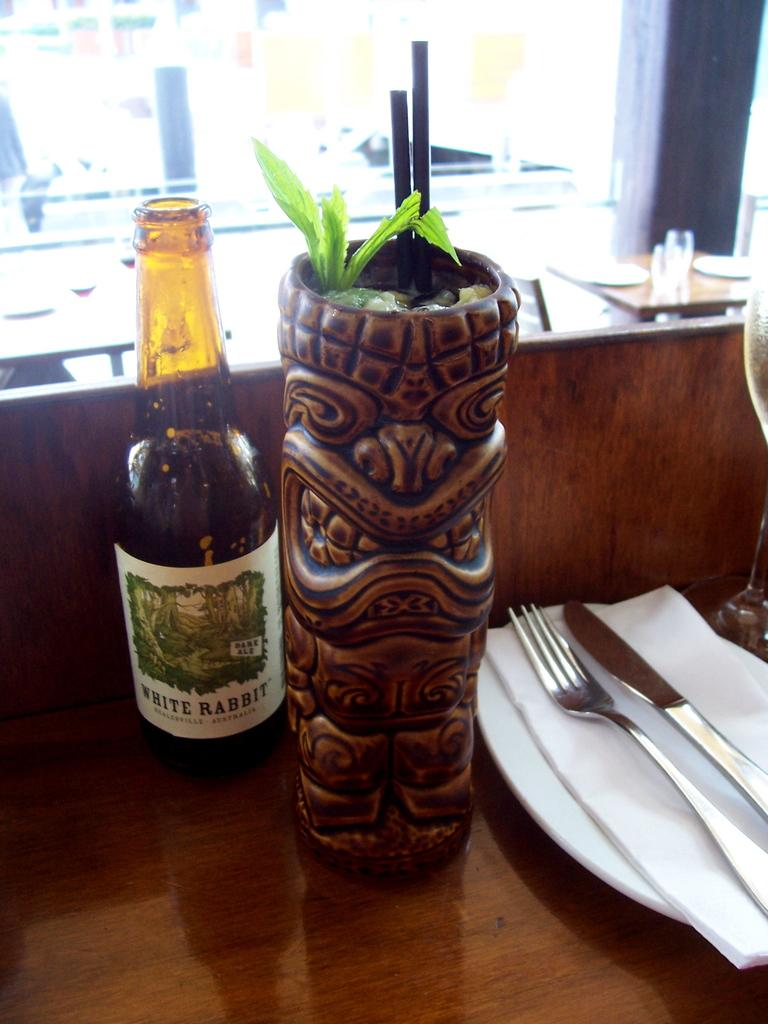<image>
Present a compact description of the photo's key features. A bottle of White Rabbit beer next to a totem pole planter 